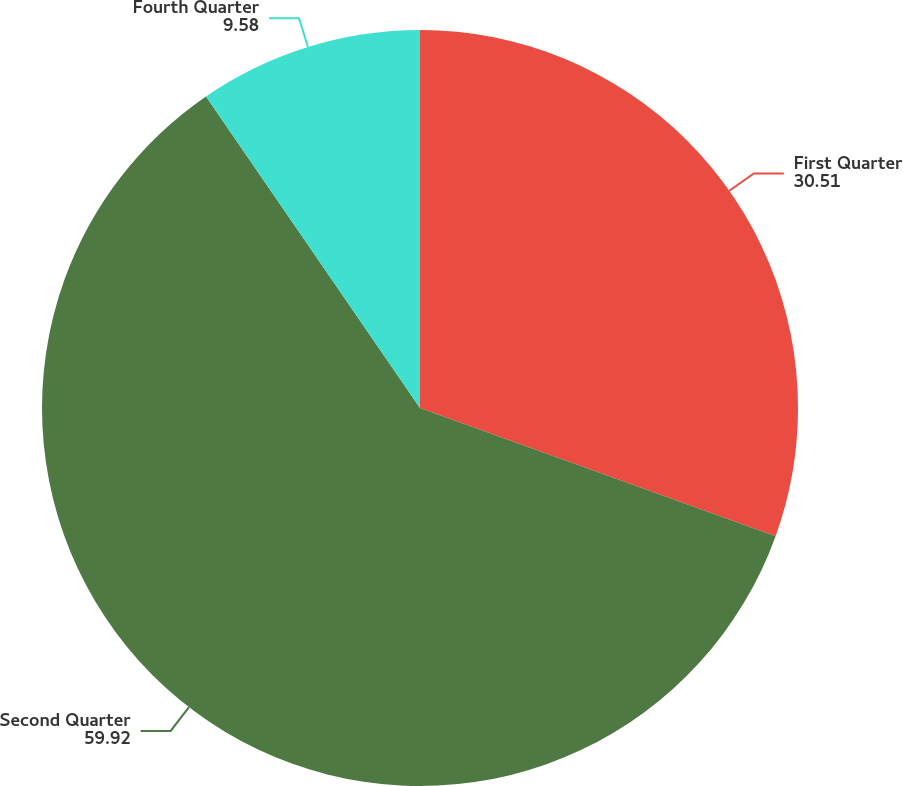Convert chart. <chart><loc_0><loc_0><loc_500><loc_500><pie_chart><fcel>First Quarter<fcel>Second Quarter<fcel>Fourth Quarter<nl><fcel>30.51%<fcel>59.92%<fcel>9.58%<nl></chart> 